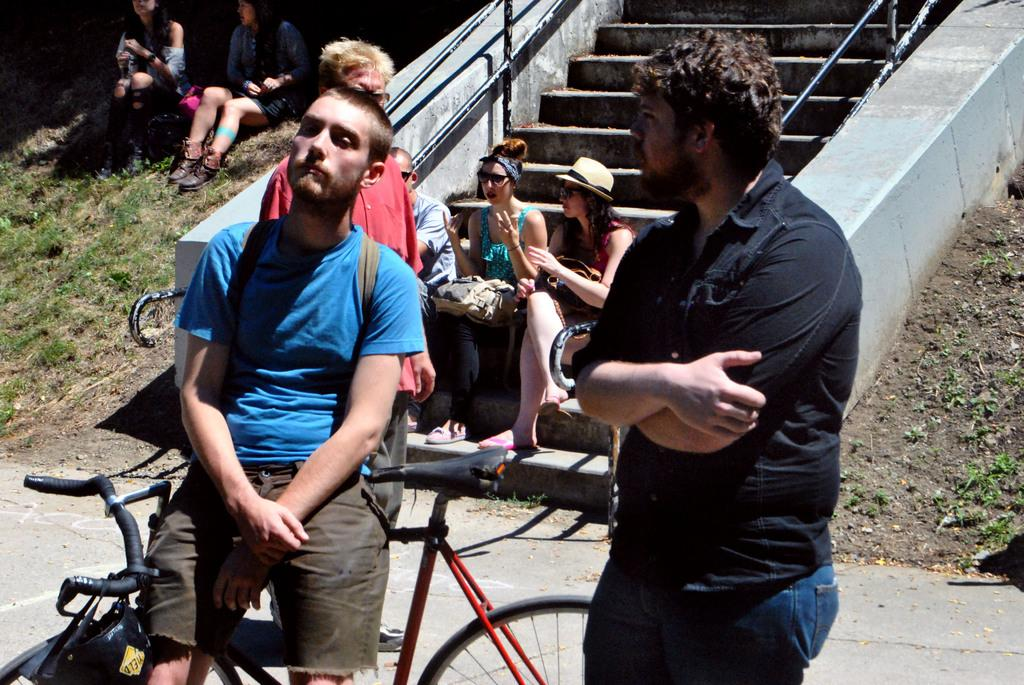How many girls are sitting in the image? There are two girls sitting in the image. Where are the girls sitting? One girl is sitting on steps, and the other girl is sitting on the ground. What are the boys doing in the image? The boys are standing beside a bicycle. What type of flower can be seen growing near the farm in the image? There is no flower or farm present in the image; it features two girls sitting and two boys standing beside a bicycle. 